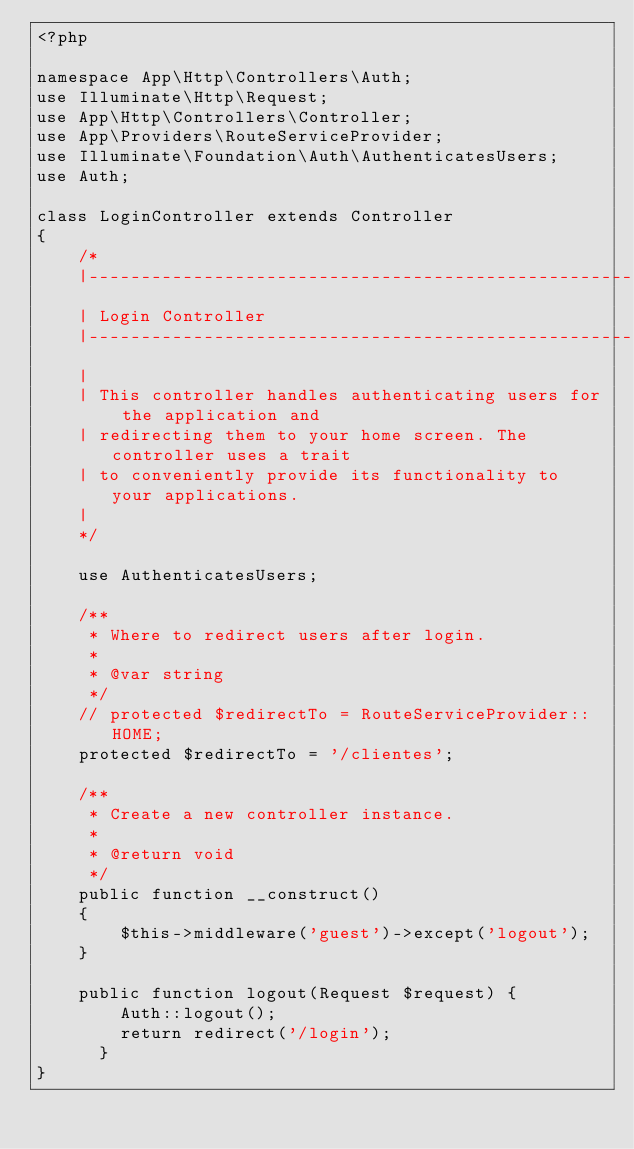Convert code to text. <code><loc_0><loc_0><loc_500><loc_500><_PHP_><?php

namespace App\Http\Controllers\Auth;
use Illuminate\Http\Request;
use App\Http\Controllers\Controller;
use App\Providers\RouteServiceProvider;
use Illuminate\Foundation\Auth\AuthenticatesUsers;
use Auth;

class LoginController extends Controller
{
    /*
    |--------------------------------------------------------------------------
    | Login Controller
    |--------------------------------------------------------------------------
    |
    | This controller handles authenticating users for the application and
    | redirecting them to your home screen. The controller uses a trait
    | to conveniently provide its functionality to your applications.
    |
    */

    use AuthenticatesUsers;

    /**
     * Where to redirect users after login.
     *
     * @var string
     */
    // protected $redirectTo = RouteServiceProvider::HOME;
    protected $redirectTo = '/clientes';

    /**
     * Create a new controller instance.
     *
     * @return void
     */
    public function __construct()
    {
        $this->middleware('guest')->except('logout');
    }

    public function logout(Request $request) {
        Auth::logout();
        return redirect('/login');
      }
}
</code> 